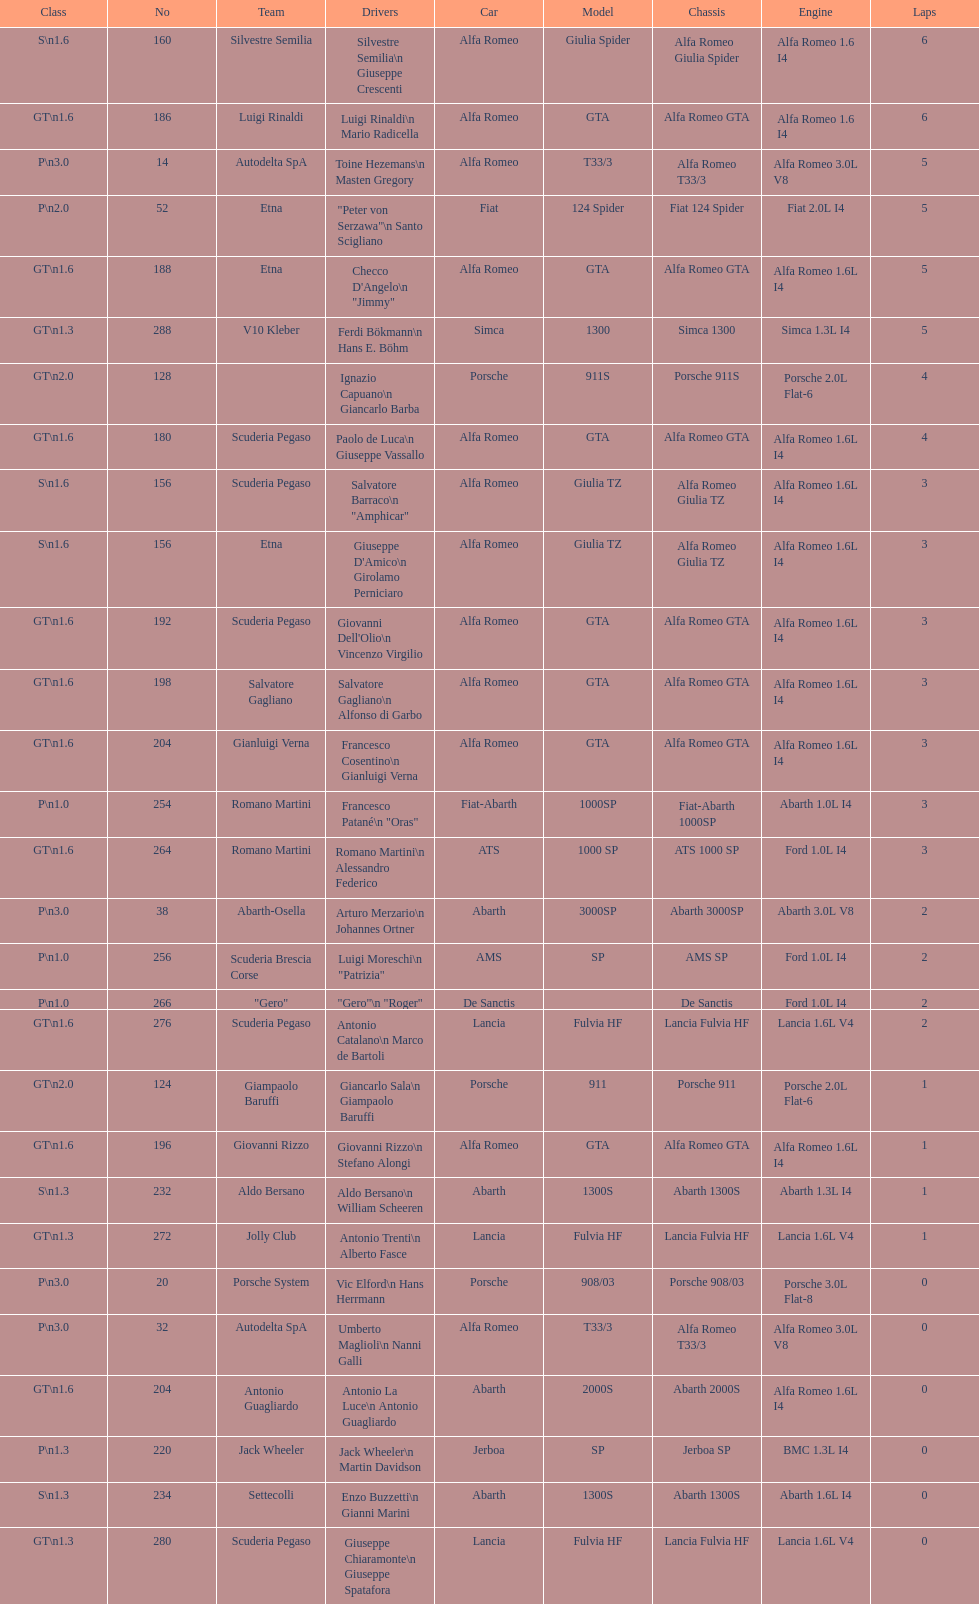How many drivers are from italy? 48. Parse the full table. {'header': ['Class', 'No', 'Team', 'Drivers', 'Car', 'Model', 'Chassis', 'Engine', 'Laps'], 'rows': [['S\\n1.6', '160', 'Silvestre Semilia', 'Silvestre Semilia\\n Giuseppe Crescenti', 'Alfa Romeo', 'Giulia Spider', 'Alfa Romeo Giulia Spider', 'Alfa Romeo 1.6 I4', '6'], ['GT\\n1.6', '186', 'Luigi Rinaldi', 'Luigi Rinaldi\\n Mario Radicella', 'Alfa Romeo', 'GTA', 'Alfa Romeo GTA', 'Alfa Romeo 1.6 I4', '6'], ['P\\n3.0', '14', 'Autodelta SpA', 'Toine Hezemans\\n Masten Gregory', 'Alfa Romeo', 'T33/3', 'Alfa Romeo T33/3', 'Alfa Romeo 3.0L V8', '5'], ['P\\n2.0', '52', 'Etna', '"Peter von Serzawa"\\n Santo Scigliano', 'Fiat', '124 Spider', 'Fiat 124 Spider', 'Fiat 2.0L I4', '5'], ['GT\\n1.6', '188', 'Etna', 'Checco D\'Angelo\\n "Jimmy"', 'Alfa Romeo', 'GTA', 'Alfa Romeo GTA', 'Alfa Romeo 1.6L I4', '5'], ['GT\\n1.3', '288', 'V10 Kleber', 'Ferdi Bökmann\\n Hans E. Böhm', 'Simca', '1300', 'Simca 1300', 'Simca 1.3L I4', '5'], ['GT\\n2.0', '128', '', 'Ignazio Capuano\\n Giancarlo Barba', 'Porsche', '911S', 'Porsche 911S', 'Porsche 2.0L Flat-6', '4'], ['GT\\n1.6', '180', 'Scuderia Pegaso', 'Paolo de Luca\\n Giuseppe Vassallo', 'Alfa Romeo', 'GTA', 'Alfa Romeo GTA', 'Alfa Romeo 1.6L I4', '4'], ['S\\n1.6', '156', 'Scuderia Pegaso', 'Salvatore Barraco\\n "Amphicar"', 'Alfa Romeo', 'Giulia TZ', 'Alfa Romeo Giulia TZ', 'Alfa Romeo 1.6L I4', '3'], ['S\\n1.6', '156', 'Etna', "Giuseppe D'Amico\\n Girolamo Perniciaro", 'Alfa Romeo', 'Giulia TZ', 'Alfa Romeo Giulia TZ', 'Alfa Romeo 1.6L I4', '3'], ['GT\\n1.6', '192', 'Scuderia Pegaso', "Giovanni Dell'Olio\\n Vincenzo Virgilio", 'Alfa Romeo', 'GTA', 'Alfa Romeo GTA', 'Alfa Romeo 1.6L I4', '3'], ['GT\\n1.6', '198', 'Salvatore Gagliano', 'Salvatore Gagliano\\n Alfonso di Garbo', 'Alfa Romeo', 'GTA', 'Alfa Romeo GTA', 'Alfa Romeo 1.6L I4', '3'], ['GT\\n1.6', '204', 'Gianluigi Verna', 'Francesco Cosentino\\n Gianluigi Verna', 'Alfa Romeo', 'GTA', 'Alfa Romeo GTA', 'Alfa Romeo 1.6L I4', '3'], ['P\\n1.0', '254', 'Romano Martini', 'Francesco Patané\\n "Oras"', 'Fiat-Abarth', '1000SP', 'Fiat-Abarth 1000SP', 'Abarth 1.0L I4', '3'], ['GT\\n1.6', '264', 'Romano Martini', 'Romano Martini\\n Alessandro Federico', 'ATS', '1000 SP', 'ATS 1000 SP', 'Ford 1.0L I4', '3'], ['P\\n3.0', '38', 'Abarth-Osella', 'Arturo Merzario\\n Johannes Ortner', 'Abarth', '3000SP', 'Abarth 3000SP', 'Abarth 3.0L V8', '2'], ['P\\n1.0', '256', 'Scuderia Brescia Corse', 'Luigi Moreschi\\n "Patrizia"', 'AMS', 'SP', 'AMS SP', 'Ford 1.0L I4', '2'], ['P\\n1.0', '266', '"Gero"', '"Gero"\\n "Roger"', 'De Sanctis', '', 'De Sanctis', 'Ford 1.0L I4', '2'], ['GT\\n1.6', '276', 'Scuderia Pegaso', 'Antonio Catalano\\n Marco de Bartoli', 'Lancia', 'Fulvia HF', 'Lancia Fulvia HF', 'Lancia 1.6L V4', '2'], ['GT\\n2.0', '124', 'Giampaolo Baruffi', 'Giancarlo Sala\\n Giampaolo Baruffi', 'Porsche', '911', 'Porsche 911', 'Porsche 2.0L Flat-6', '1'], ['GT\\n1.6', '196', 'Giovanni Rizzo', 'Giovanni Rizzo\\n Stefano Alongi', 'Alfa Romeo', 'GTA', 'Alfa Romeo GTA', 'Alfa Romeo 1.6L I4', '1'], ['S\\n1.3', '232', 'Aldo Bersano', 'Aldo Bersano\\n William Scheeren', 'Abarth', '1300S', 'Abarth 1300S', 'Abarth 1.3L I4', '1'], ['GT\\n1.3', '272', 'Jolly Club', 'Antonio Trenti\\n Alberto Fasce', 'Lancia', 'Fulvia HF', 'Lancia Fulvia HF', 'Lancia 1.6L V4', '1'], ['P\\n3.0', '20', 'Porsche System', 'Vic Elford\\n Hans Herrmann', 'Porsche', '908/03', 'Porsche 908/03', 'Porsche 3.0L Flat-8', '0'], ['P\\n3.0', '32', 'Autodelta SpA', 'Umberto Maglioli\\n Nanni Galli', 'Alfa Romeo', 'T33/3', 'Alfa Romeo T33/3', 'Alfa Romeo 3.0L V8', '0'], ['GT\\n1.6', '204', 'Antonio Guagliardo', 'Antonio La Luce\\n Antonio Guagliardo', 'Abarth', '2000S', 'Abarth 2000S', 'Alfa Romeo 1.6L I4', '0'], ['P\\n1.3', '220', 'Jack Wheeler', 'Jack Wheeler\\n Martin Davidson', 'Jerboa', 'SP', 'Jerboa SP', 'BMC 1.3L I4', '0'], ['S\\n1.3', '234', 'Settecolli', 'Enzo Buzzetti\\n Gianni Marini', 'Abarth', '1300S', 'Abarth 1300S', 'Abarth 1.6L I4', '0'], ['GT\\n1.3', '280', 'Scuderia Pegaso', 'Giuseppe Chiaramonte\\n Giuseppe Spatafora', 'Lancia', 'Fulvia HF', 'Lancia Fulvia HF', 'Lancia 1.6L V4', '0']]} 